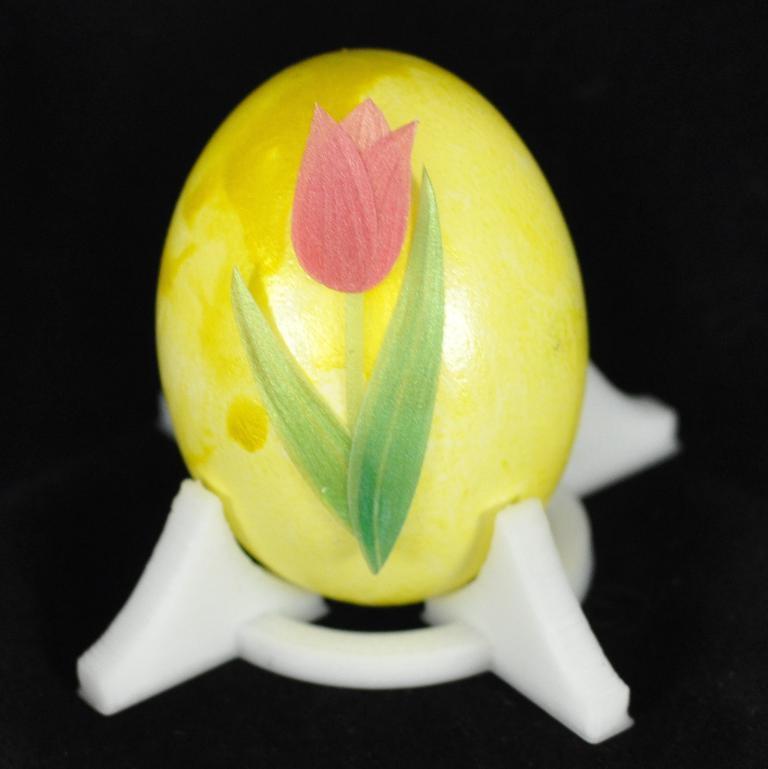Please provide a concise description of this image. In this image we can see the painting of a flower on the yellow colored object, which is on the stand, and the background is black in color. 